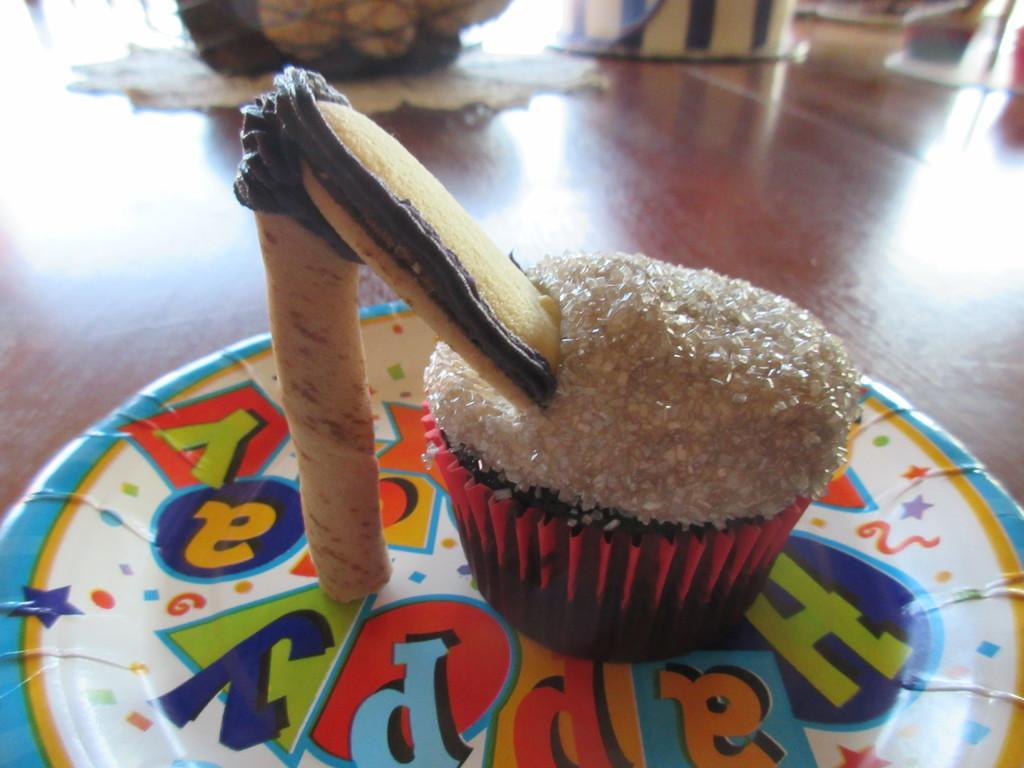Could you give a brief overview of what you see in this image? In this image we can see a cup cake with a wafer in a plate which is placed on the table. At the top of the image we can see some objects. 